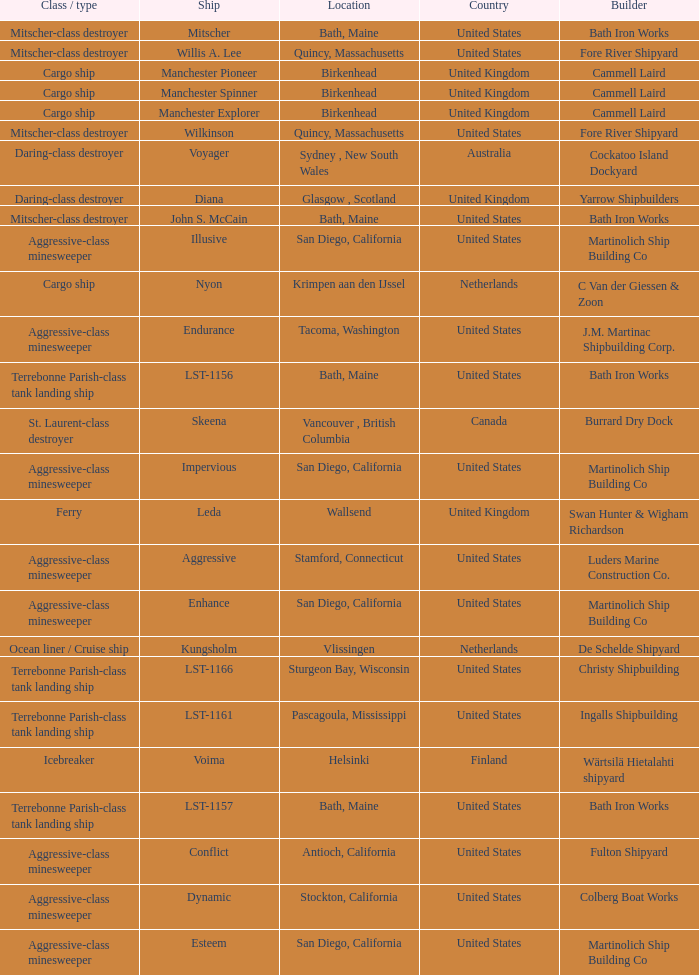What Ship was Built by Cammell Laird? Manchester Pioneer, Manchester Spinner, Manchester Explorer. 